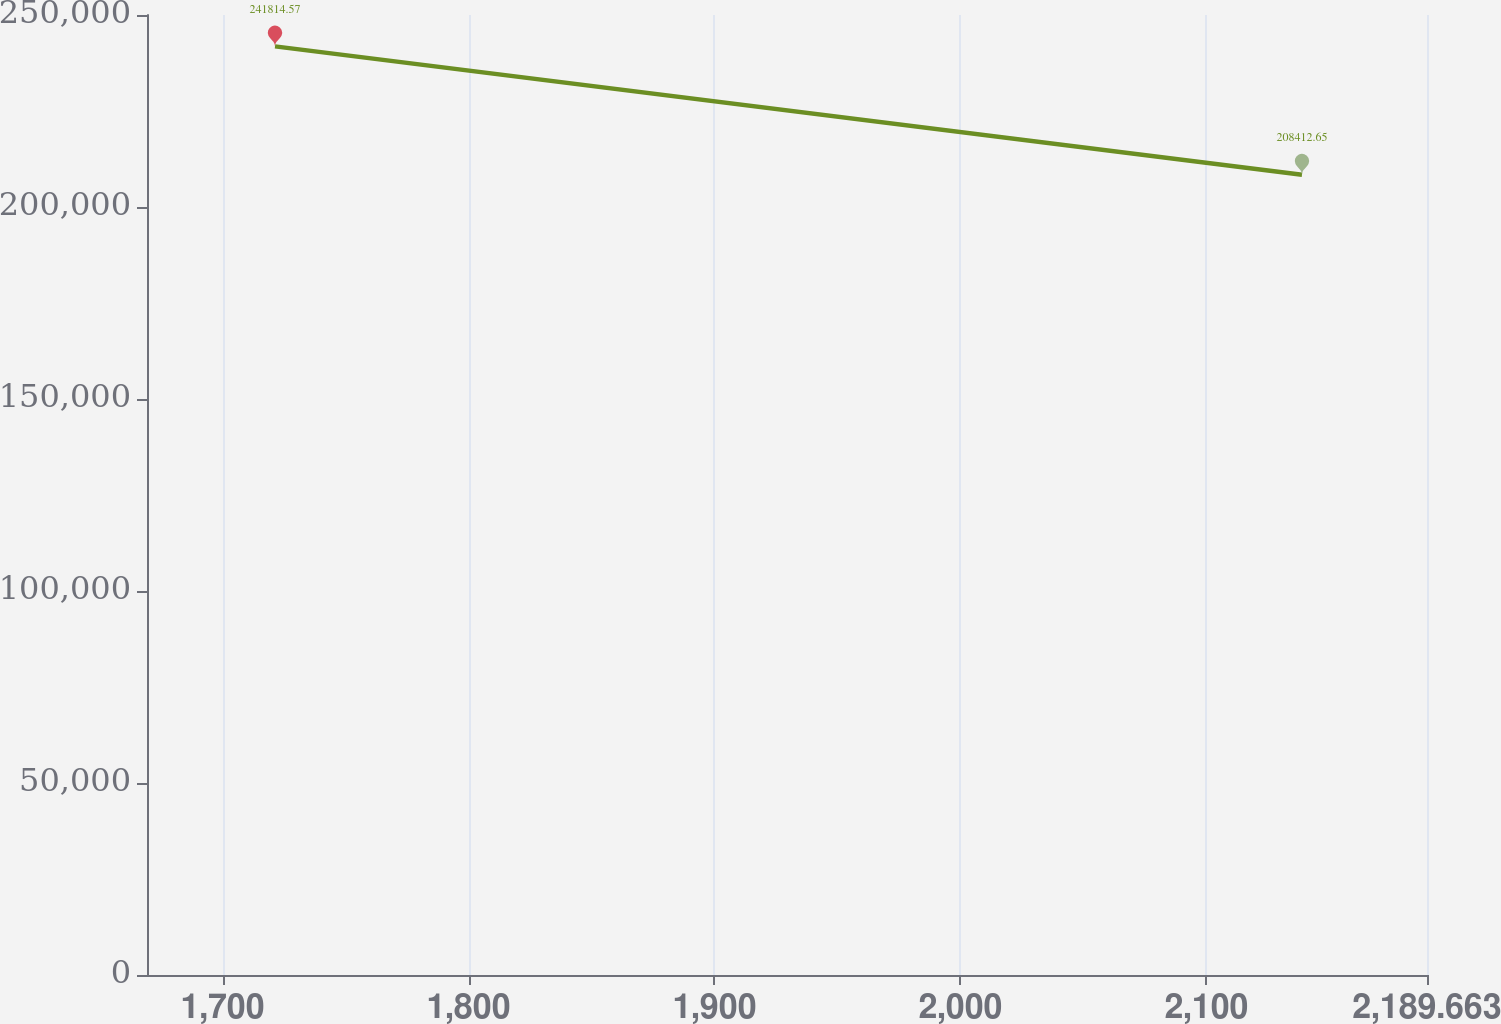<chart> <loc_0><loc_0><loc_500><loc_500><line_chart><ecel><fcel>2009 .............................................................. $ 243,198<nl><fcel>1721.33<fcel>241815<nl><fcel>2138.84<fcel>208413<nl><fcel>2192.32<fcel>196899<nl><fcel>2241.7<fcel>202289<nl></chart> 